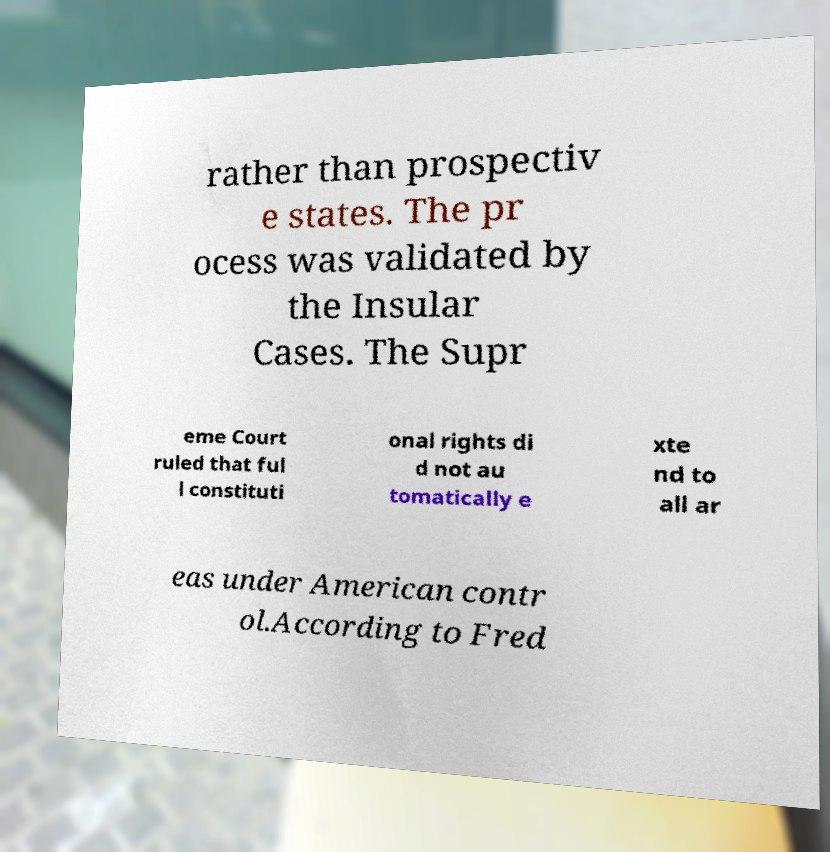For documentation purposes, I need the text within this image transcribed. Could you provide that? rather than prospectiv e states. The pr ocess was validated by the Insular Cases. The Supr eme Court ruled that ful l constituti onal rights di d not au tomatically e xte nd to all ar eas under American contr ol.According to Fred 